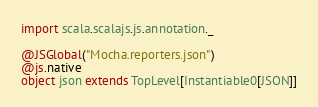Convert code to text. <code><loc_0><loc_0><loc_500><loc_500><_Scala_>import scala.scalajs.js.annotation._

@JSGlobal("Mocha.reporters.json")
@js.native
object json extends TopLevel[Instantiable0[JSON]]

</code> 